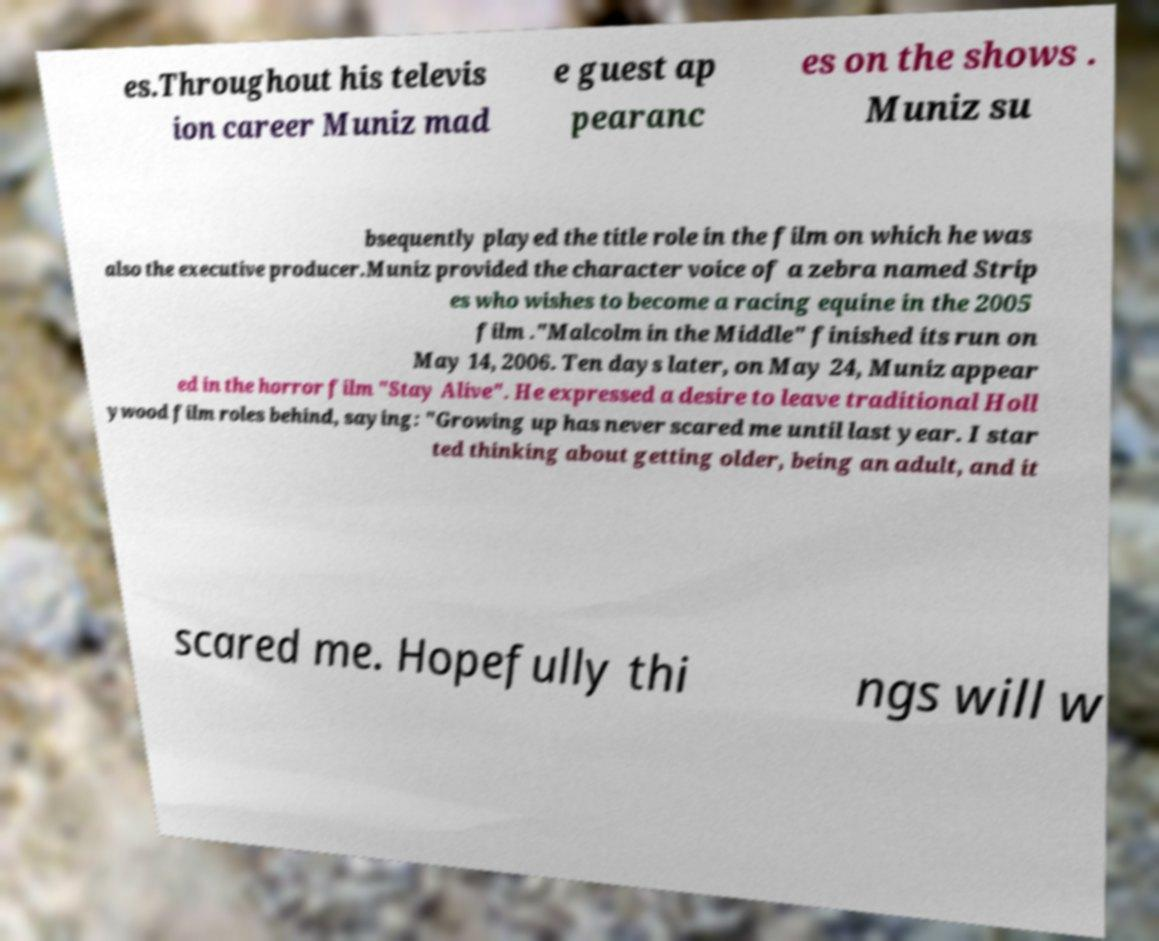Could you extract and type out the text from this image? es.Throughout his televis ion career Muniz mad e guest ap pearanc es on the shows . Muniz su bsequently played the title role in the film on which he was also the executive producer.Muniz provided the character voice of a zebra named Strip es who wishes to become a racing equine in the 2005 film ."Malcolm in the Middle" finished its run on May 14, 2006. Ten days later, on May 24, Muniz appear ed in the horror film "Stay Alive". He expressed a desire to leave traditional Holl ywood film roles behind, saying: "Growing up has never scared me until last year. I star ted thinking about getting older, being an adult, and it scared me. Hopefully thi ngs will w 